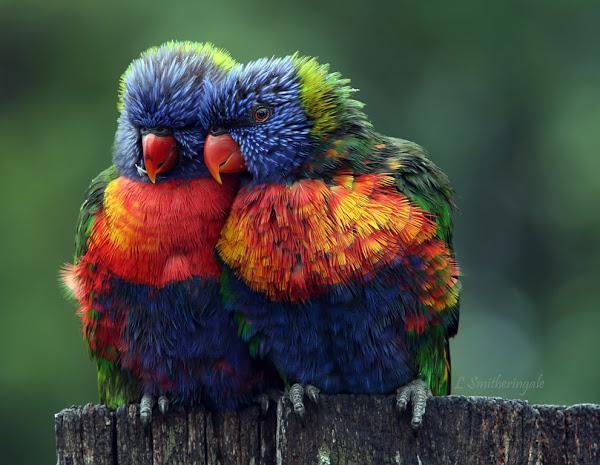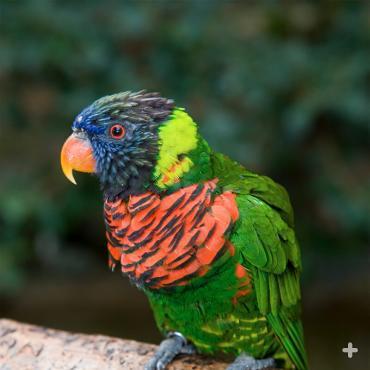The first image is the image on the left, the second image is the image on the right. For the images displayed, is the sentence "All birds are alone." factually correct? Answer yes or no. No. 